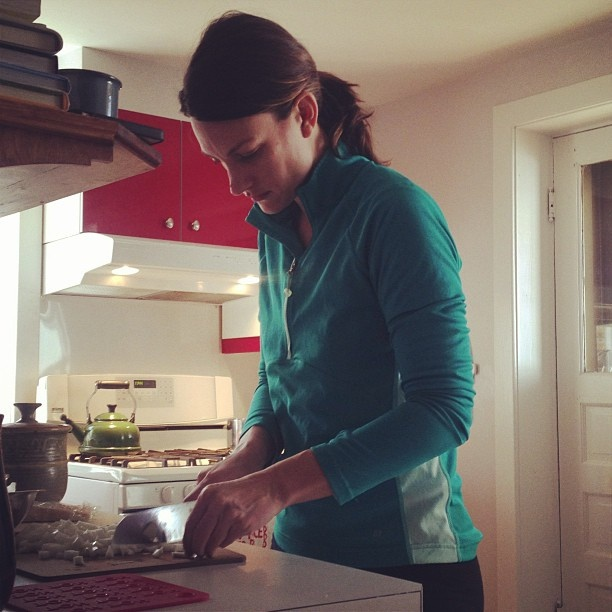Describe the objects in this image and their specific colors. I can see people in black, darkblue, teal, and maroon tones, oven in black, darkgray, lightgray, tan, and gray tones, knife in black, lightgray, gray, and darkgray tones, bowl in black, gray, and darkgray tones, and book in black and brown tones in this image. 